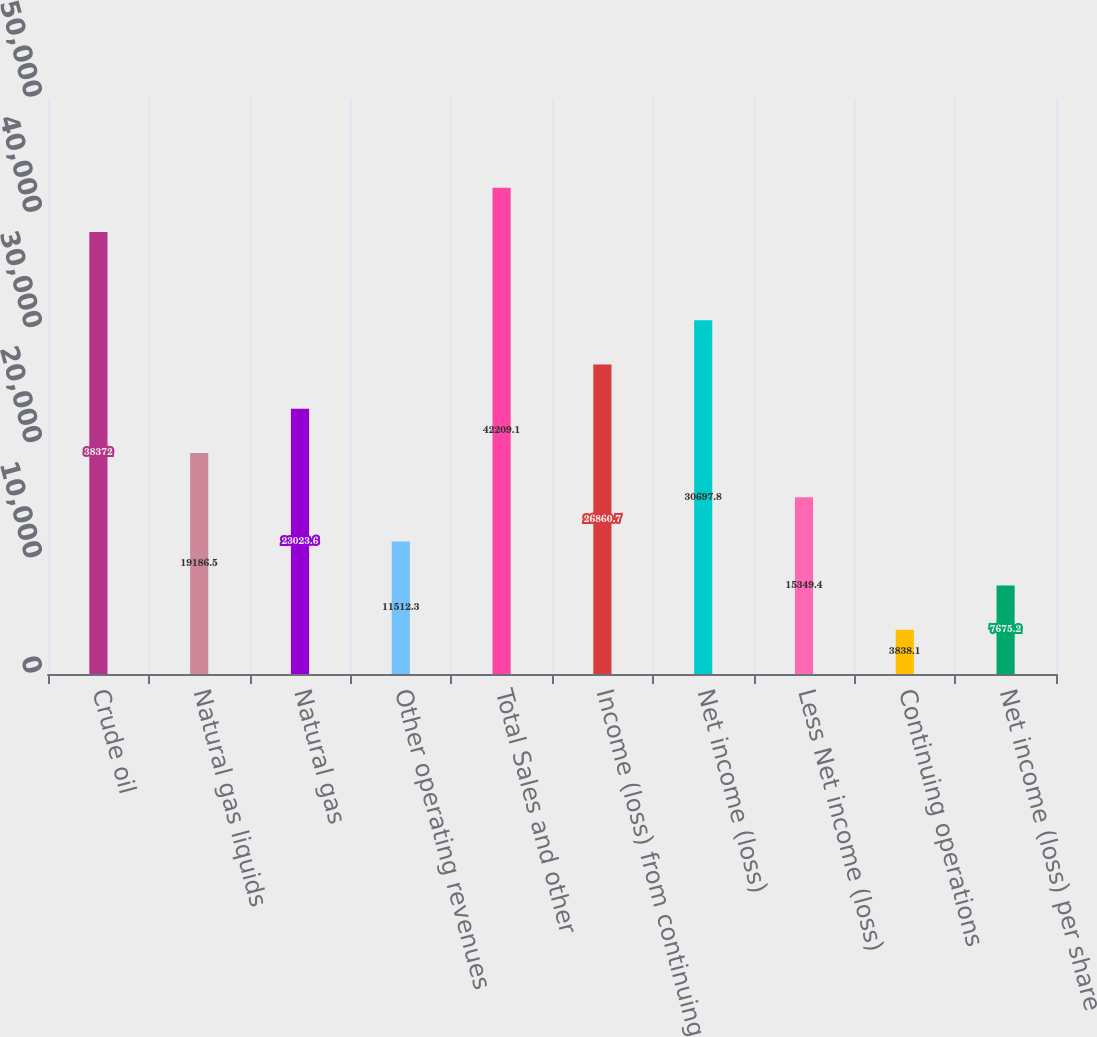Convert chart to OTSL. <chart><loc_0><loc_0><loc_500><loc_500><bar_chart><fcel>Crude oil<fcel>Natural gas liquids<fcel>Natural gas<fcel>Other operating revenues<fcel>Total Sales and other<fcel>Income (loss) from continuing<fcel>Net income (loss)<fcel>Less Net income (loss)<fcel>Continuing operations<fcel>Net income (loss) per share<nl><fcel>38372<fcel>19186.5<fcel>23023.6<fcel>11512.3<fcel>42209.1<fcel>26860.7<fcel>30697.8<fcel>15349.4<fcel>3838.1<fcel>7675.2<nl></chart> 